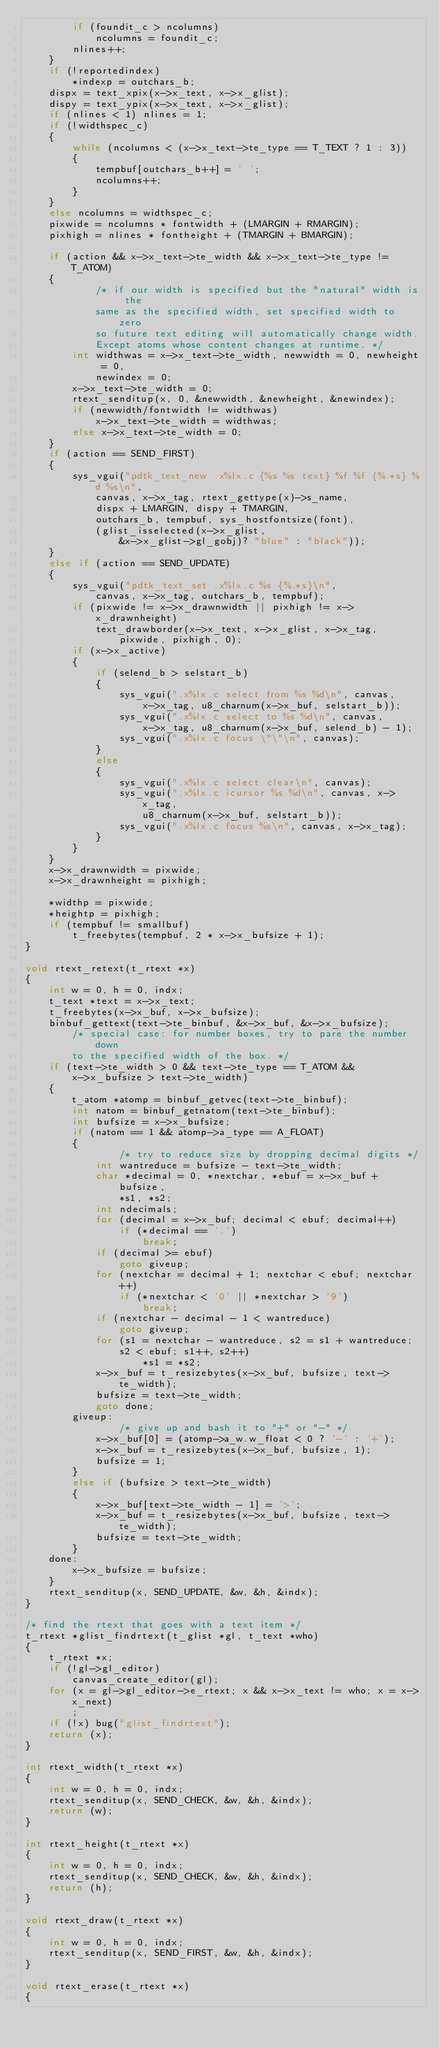Convert code to text. <code><loc_0><loc_0><loc_500><loc_500><_C_>        if (foundit_c > ncolumns)
            ncolumns = foundit_c;
        nlines++;
    }
    if (!reportedindex)
        *indexp = outchars_b;
    dispx = text_xpix(x->x_text, x->x_glist);
    dispy = text_ypix(x->x_text, x->x_glist);
    if (nlines < 1) nlines = 1;
    if (!widthspec_c)
    {
        while (ncolumns < (x->x_text->te_type == T_TEXT ? 1 : 3))
        {
            tempbuf[outchars_b++] = ' ';
            ncolumns++;
        }
    }
    else ncolumns = widthspec_c;
    pixwide = ncolumns * fontwidth + (LMARGIN + RMARGIN);
    pixhigh = nlines * fontheight + (TMARGIN + BMARGIN);

    if (action && x->x_text->te_width && x->x_text->te_type != T_ATOM)
    {
            /* if our width is specified but the "natural" width is the
            same as the specified width, set specified width to zero
            so future text editing will automatically change width.
            Except atoms whose content changes at runtime. */
        int widthwas = x->x_text->te_width, newwidth = 0, newheight = 0,
            newindex = 0;
        x->x_text->te_width = 0;
        rtext_senditup(x, 0, &newwidth, &newheight, &newindex);
        if (newwidth/fontwidth != widthwas)
            x->x_text->te_width = widthwas;
        else x->x_text->te_width = 0;
    }
    if (action == SEND_FIRST)
    {
        sys_vgui("pdtk_text_new .x%lx.c {%s %s text} %f %f {%.*s} %d %s\n",
            canvas, x->x_tag, rtext_gettype(x)->s_name,
            dispx + LMARGIN, dispy + TMARGIN,
            outchars_b, tempbuf, sys_hostfontsize(font),
            (glist_isselected(x->x_glist,
                &x->x_glist->gl_gobj)? "blue" : "black"));
    }
    else if (action == SEND_UPDATE)
    {
        sys_vgui("pdtk_text_set .x%lx.c %s {%.*s}\n",
            canvas, x->x_tag, outchars_b, tempbuf);
        if (pixwide != x->x_drawnwidth || pixhigh != x->x_drawnheight) 
            text_drawborder(x->x_text, x->x_glist, x->x_tag,
                pixwide, pixhigh, 0);
        if (x->x_active)
        {
            if (selend_b > selstart_b)
            {
                sys_vgui(".x%lx.c select from %s %d\n", canvas, 
                    x->x_tag, u8_charnum(x->x_buf, selstart_b));
                sys_vgui(".x%lx.c select to %s %d\n", canvas, 
                    x->x_tag, u8_charnum(x->x_buf, selend_b) - 1);
                sys_vgui(".x%lx.c focus \"\"\n", canvas);        
            }
            else
            {
                sys_vgui(".x%lx.c select clear\n", canvas);
                sys_vgui(".x%lx.c icursor %s %d\n", canvas, x->x_tag,
                    u8_charnum(x->x_buf, selstart_b));
                sys_vgui(".x%lx.c focus %s\n", canvas, x->x_tag);        
            }
        }
    }
    x->x_drawnwidth = pixwide;
    x->x_drawnheight = pixhigh;
    
    *widthp = pixwide;
    *heightp = pixhigh;
    if (tempbuf != smallbuf)
        t_freebytes(tempbuf, 2 * x->x_bufsize + 1);
}

void rtext_retext(t_rtext *x)
{
    int w = 0, h = 0, indx;
    t_text *text = x->x_text;
    t_freebytes(x->x_buf, x->x_bufsize);
    binbuf_gettext(text->te_binbuf, &x->x_buf, &x->x_bufsize);
        /* special case: for number boxes, try to pare the number down
        to the specified width of the box. */
    if (text->te_width > 0 && text->te_type == T_ATOM &&
        x->x_bufsize > text->te_width)
    {
        t_atom *atomp = binbuf_getvec(text->te_binbuf);
        int natom = binbuf_getnatom(text->te_binbuf);
        int bufsize = x->x_bufsize;
        if (natom == 1 && atomp->a_type == A_FLOAT)
        {
                /* try to reduce size by dropping decimal digits */
            int wantreduce = bufsize - text->te_width;
            char *decimal = 0, *nextchar, *ebuf = x->x_buf + bufsize,
                *s1, *s2;
            int ndecimals;
            for (decimal = x->x_buf; decimal < ebuf; decimal++)
                if (*decimal == '.')
                    break;
            if (decimal >= ebuf)
                goto giveup;
            for (nextchar = decimal + 1; nextchar < ebuf; nextchar++)
                if (*nextchar < '0' || *nextchar > '9')
                    break;
            if (nextchar - decimal - 1 < wantreduce)
                goto giveup;
            for (s1 = nextchar - wantreduce, s2 = s1 + wantreduce;
                s2 < ebuf; s1++, s2++)
                    *s1 = *s2;
            x->x_buf = t_resizebytes(x->x_buf, bufsize, text->te_width);
            bufsize = text->te_width;
            goto done;
        giveup:
                /* give up and bash it to "+" or "-" */
            x->x_buf[0] = (atomp->a_w.w_float < 0 ? '-' : '+');
            x->x_buf = t_resizebytes(x->x_buf, bufsize, 1);
            bufsize = 1;
        }
        else if (bufsize > text->te_width)
        {
            x->x_buf[text->te_width - 1] = '>';
            x->x_buf = t_resizebytes(x->x_buf, bufsize, text->te_width);
            bufsize = text->te_width;
        }
    done:
        x->x_bufsize = bufsize;
    }
    rtext_senditup(x, SEND_UPDATE, &w, &h, &indx);
}

/* find the rtext that goes with a text item */
t_rtext *glist_findrtext(t_glist *gl, t_text *who)
{
    t_rtext *x;
    if (!gl->gl_editor)
        canvas_create_editor(gl);
    for (x = gl->gl_editor->e_rtext; x && x->x_text != who; x = x->x_next)
        ;
    if (!x) bug("glist_findrtext");
    return (x);
}

int rtext_width(t_rtext *x)
{
    int w = 0, h = 0, indx;
    rtext_senditup(x, SEND_CHECK, &w, &h, &indx);
    return (w);
}

int rtext_height(t_rtext *x)
{
    int w = 0, h = 0, indx;
    rtext_senditup(x, SEND_CHECK, &w, &h, &indx);
    return (h);
}

void rtext_draw(t_rtext *x)
{
    int w = 0, h = 0, indx;
    rtext_senditup(x, SEND_FIRST, &w, &h, &indx);
}

void rtext_erase(t_rtext *x)
{</code> 